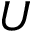<formula> <loc_0><loc_0><loc_500><loc_500>U</formula> 